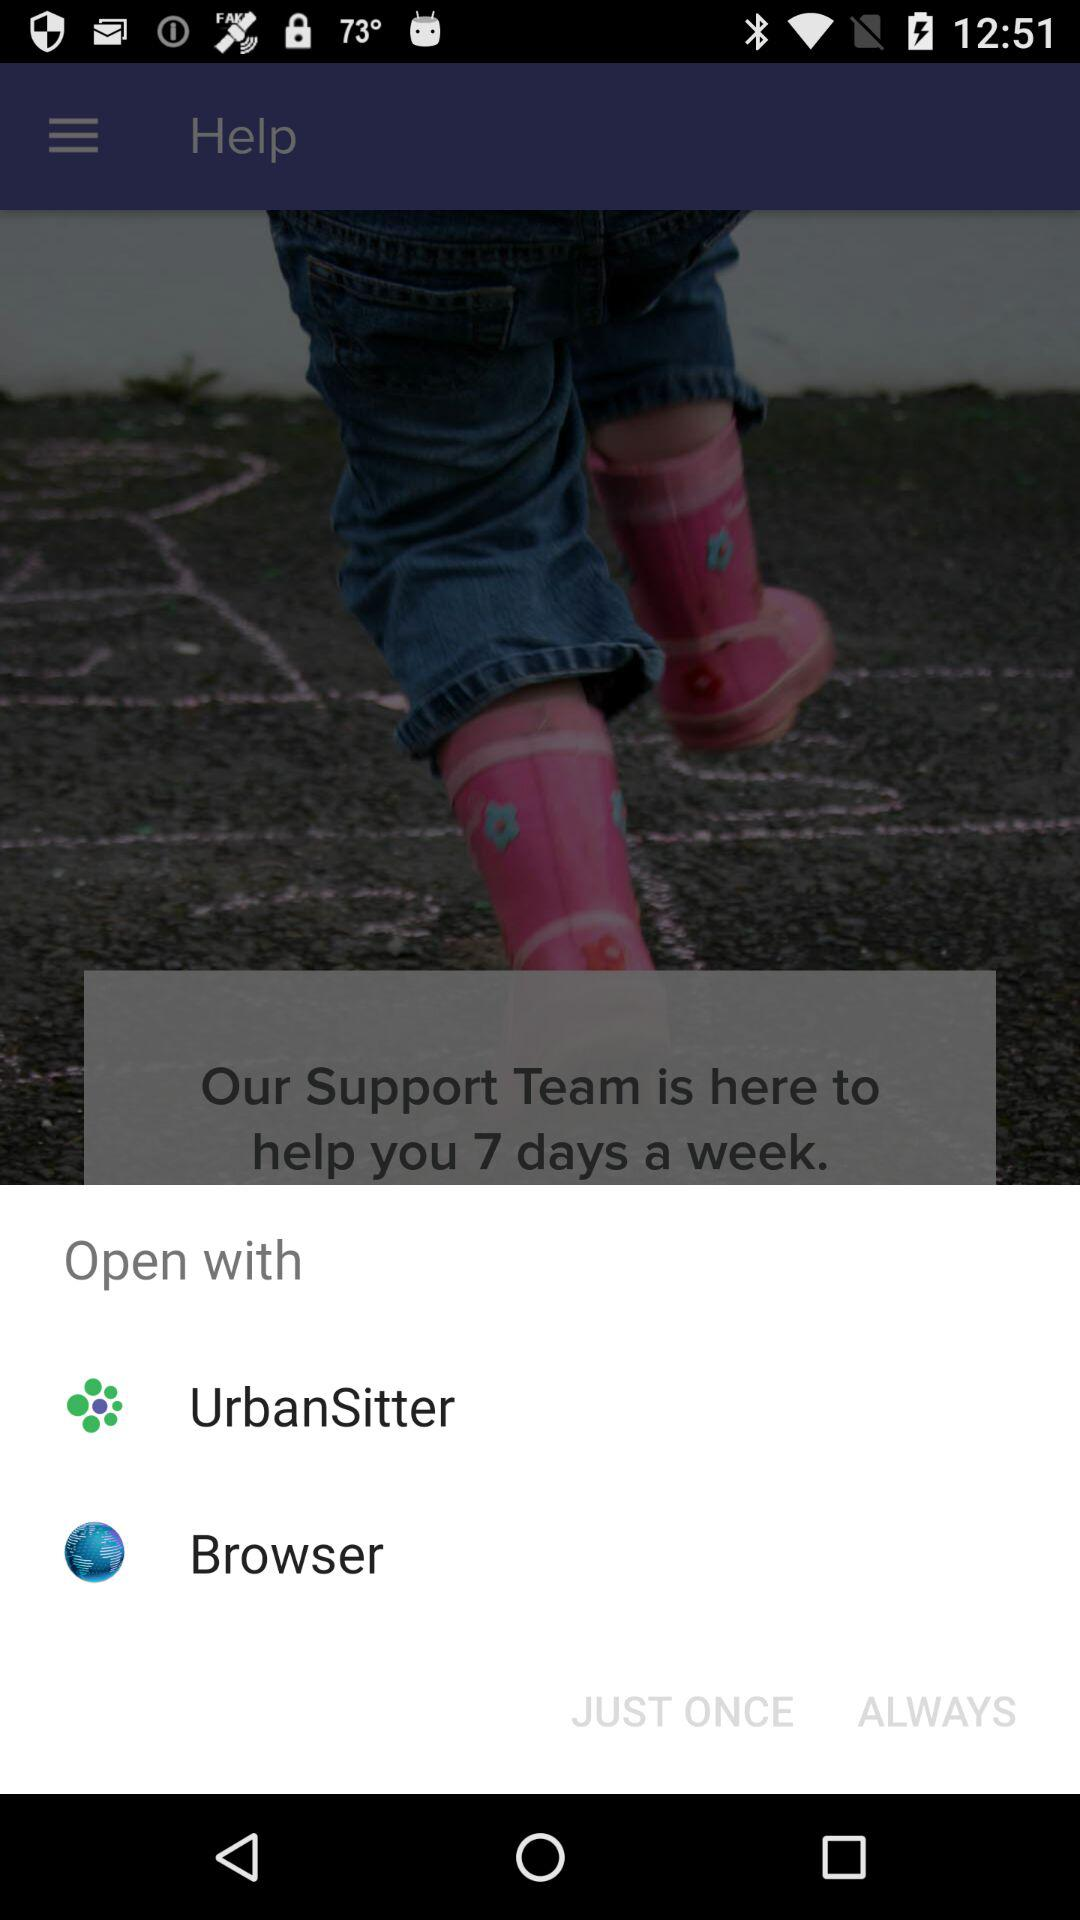What applications can be used to open the content? The applications that can be used to open the content are "UrbanSitter" and "Browser". 